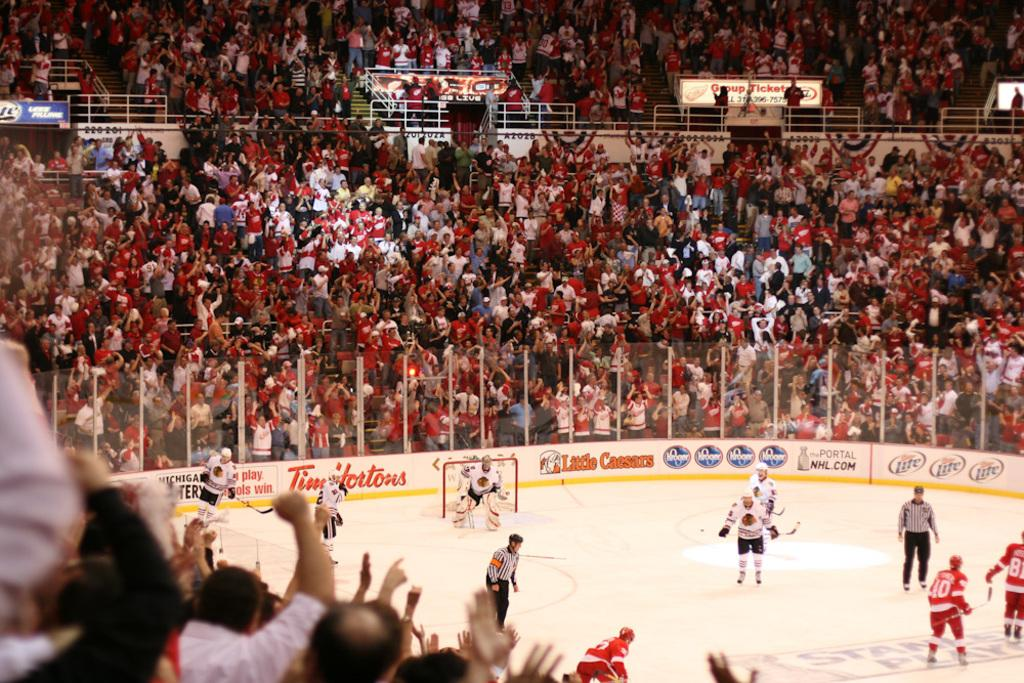What activities are the people in the image engaged in? The people in the image are playing skating and hockey. Are there any spectators in the image? Yes, there are people sitting and standing who are watching the games. How many different types of games are being played in the image? Two types of games are being played: skating and hockey. What type of treatment is being administered to the carriage in the image? There is no carriage present in the image, so no treatment can be administered to it. 